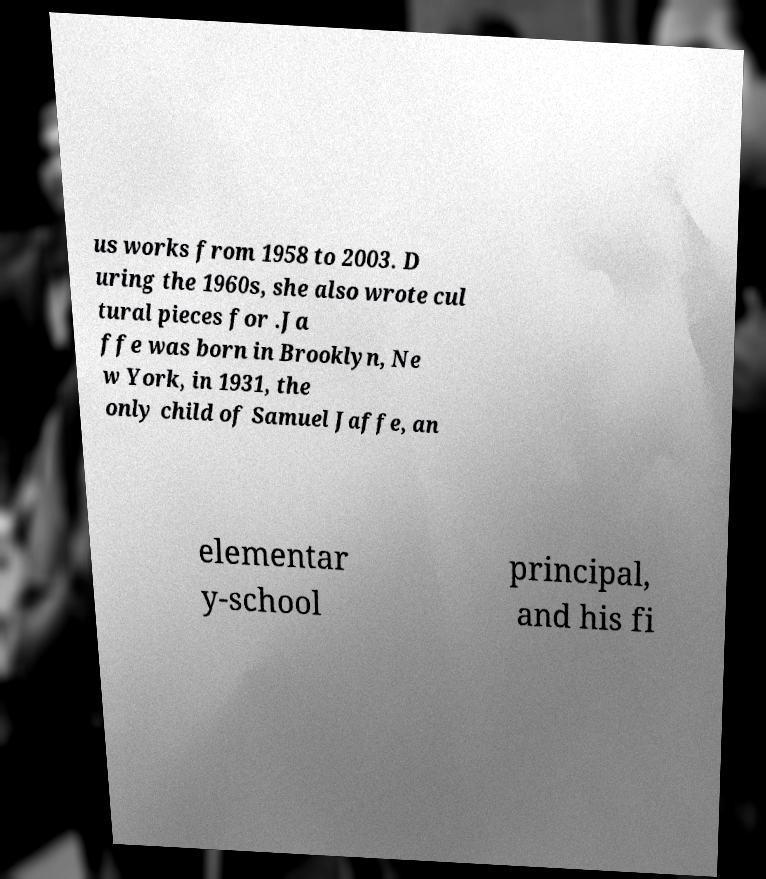There's text embedded in this image that I need extracted. Can you transcribe it verbatim? us works from 1958 to 2003. D uring the 1960s, she also wrote cul tural pieces for .Ja ffe was born in Brooklyn, Ne w York, in 1931, the only child of Samuel Jaffe, an elementar y-school principal, and his fi 